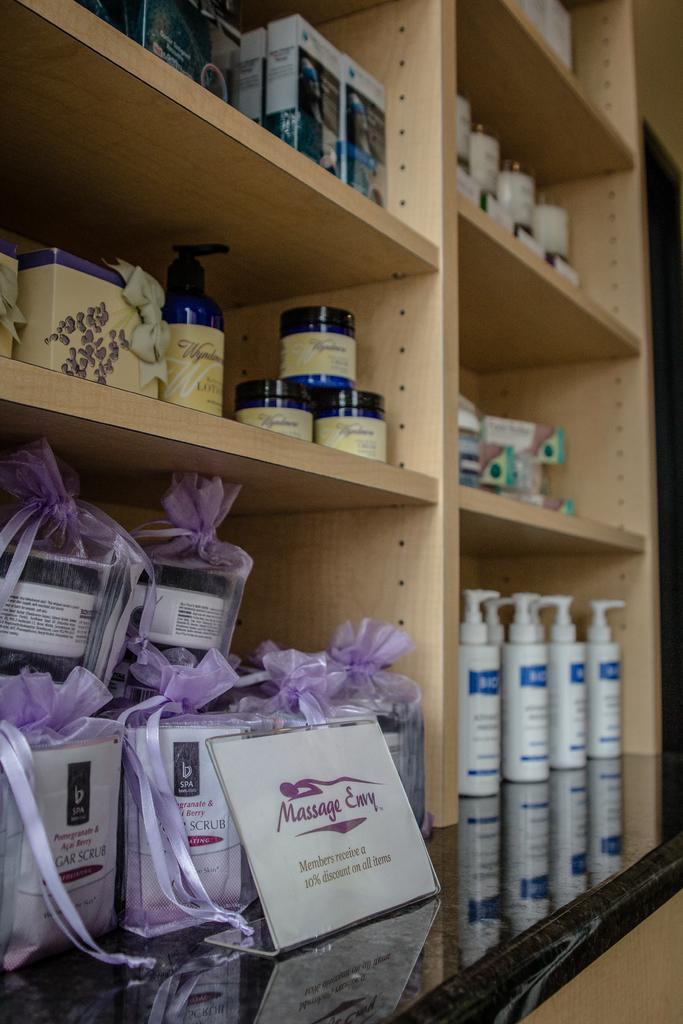In one or two sentences, can you explain what this image depicts? In this picture we can see bottles, boxes and some objects in rails, name board on a platform and in the background we can see the wall. 